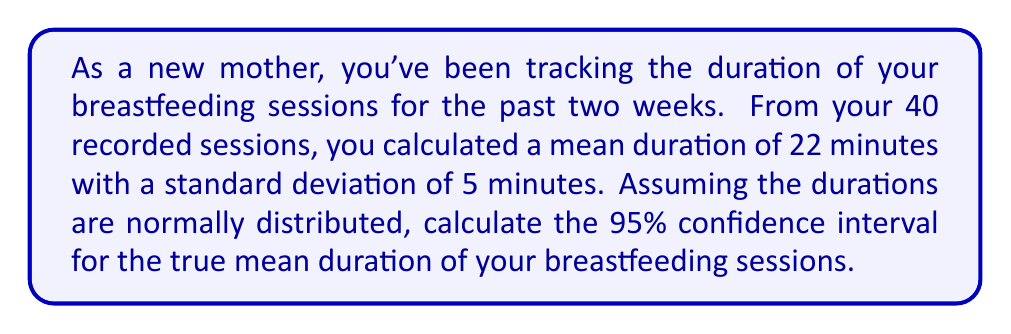Could you help me with this problem? To calculate the confidence interval for the mean, we'll use the formula:

$$ \text{CI} = \bar{x} \pm t_{\alpha/2} \cdot \frac{s}{\sqrt{n}} $$

Where:
- $\bar{x}$ is the sample mean (22 minutes)
- $s$ is the sample standard deviation (5 minutes)
- $n$ is the sample size (40 sessions)
- $t_{\alpha/2}$ is the t-value for a 95% confidence interval with $n-1$ degrees of freedom

Steps:
1) Find the t-value:
   With 39 degrees of freedom (40 - 1) and α = 0.05 (for 95% CI), $t_{0.025} = 2.023$

2) Calculate the margin of error:
   $$ \text{ME} = t_{\alpha/2} \cdot \frac{s}{\sqrt{n}} = 2.023 \cdot \frac{5}{\sqrt{40}} = 1.60 $$

3) Calculate the confidence interval:
   $$ \text{CI} = 22 \pm 1.60 $$

   Lower bound: $22 - 1.60 = 20.40$
   Upper bound: $22 + 1.60 = 23.60$
Answer: The 95% confidence interval for the true mean duration of breastfeeding sessions is (20.40, 23.60) minutes. 